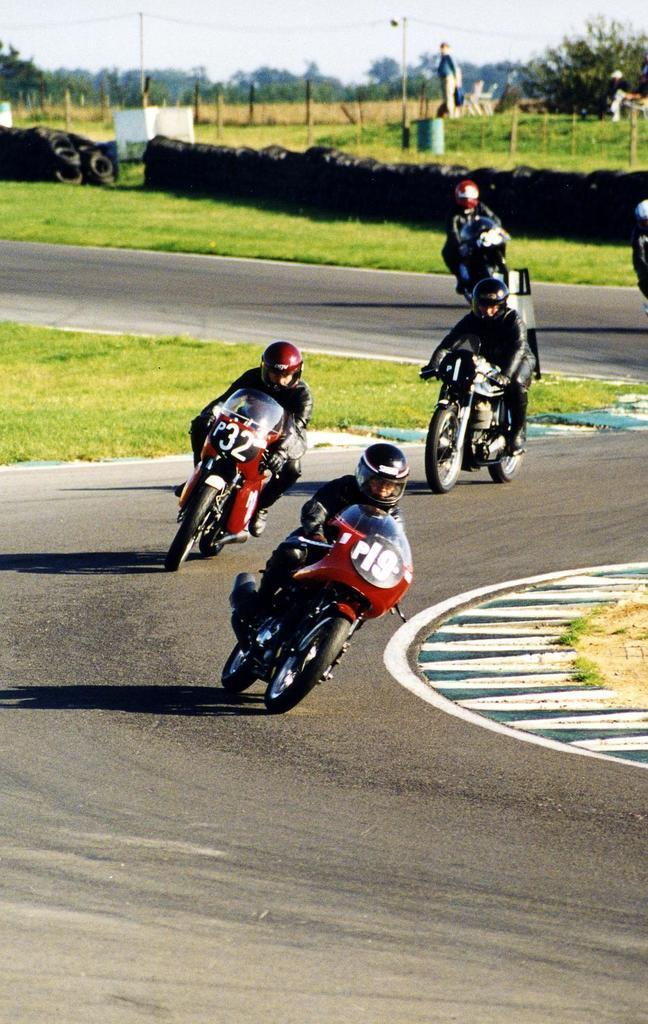In one or two sentences, can you explain what this image depicts? In this picture we can see some persons on the bikes. This is road. Here we can see grass. On the background there are trees and this is sky. 